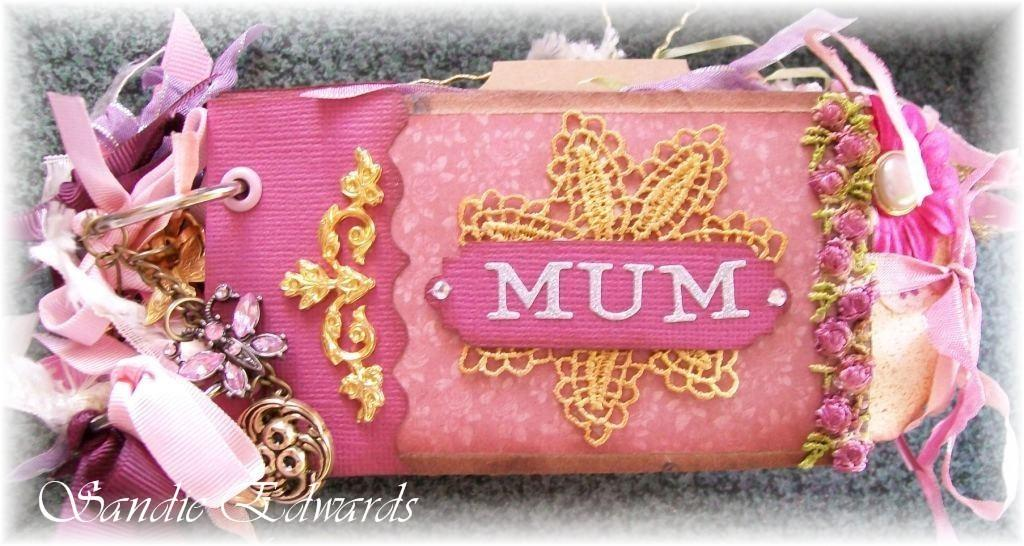What is the main subject of the image? There is an object in the image. What are some features of the object? The object has ribbons and a keychain. Is there any text present on the object? Yes, there is some text placed on the object's surface. How many ranges of string can be seen on the object in the image? There is no mention of ranges or string in the image; the object has ribbons and a keychain. 